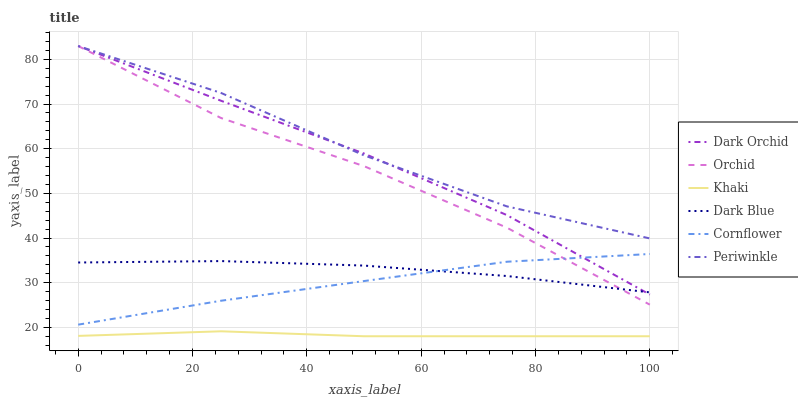Does Khaki have the minimum area under the curve?
Answer yes or no. Yes. Does Periwinkle have the maximum area under the curve?
Answer yes or no. Yes. Does Dark Orchid have the minimum area under the curve?
Answer yes or no. No. Does Dark Orchid have the maximum area under the curve?
Answer yes or no. No. Is Khaki the smoothest?
Answer yes or no. Yes. Is Orchid the roughest?
Answer yes or no. Yes. Is Dark Orchid the smoothest?
Answer yes or no. No. Is Dark Orchid the roughest?
Answer yes or no. No. Does Khaki have the lowest value?
Answer yes or no. Yes. Does Dark Orchid have the lowest value?
Answer yes or no. No. Does Orchid have the highest value?
Answer yes or no. Yes. Does Khaki have the highest value?
Answer yes or no. No. Is Khaki less than Dark Orchid?
Answer yes or no. Yes. Is Cornflower greater than Khaki?
Answer yes or no. Yes. Does Dark Orchid intersect Orchid?
Answer yes or no. Yes. Is Dark Orchid less than Orchid?
Answer yes or no. No. Is Dark Orchid greater than Orchid?
Answer yes or no. No. Does Khaki intersect Dark Orchid?
Answer yes or no. No. 